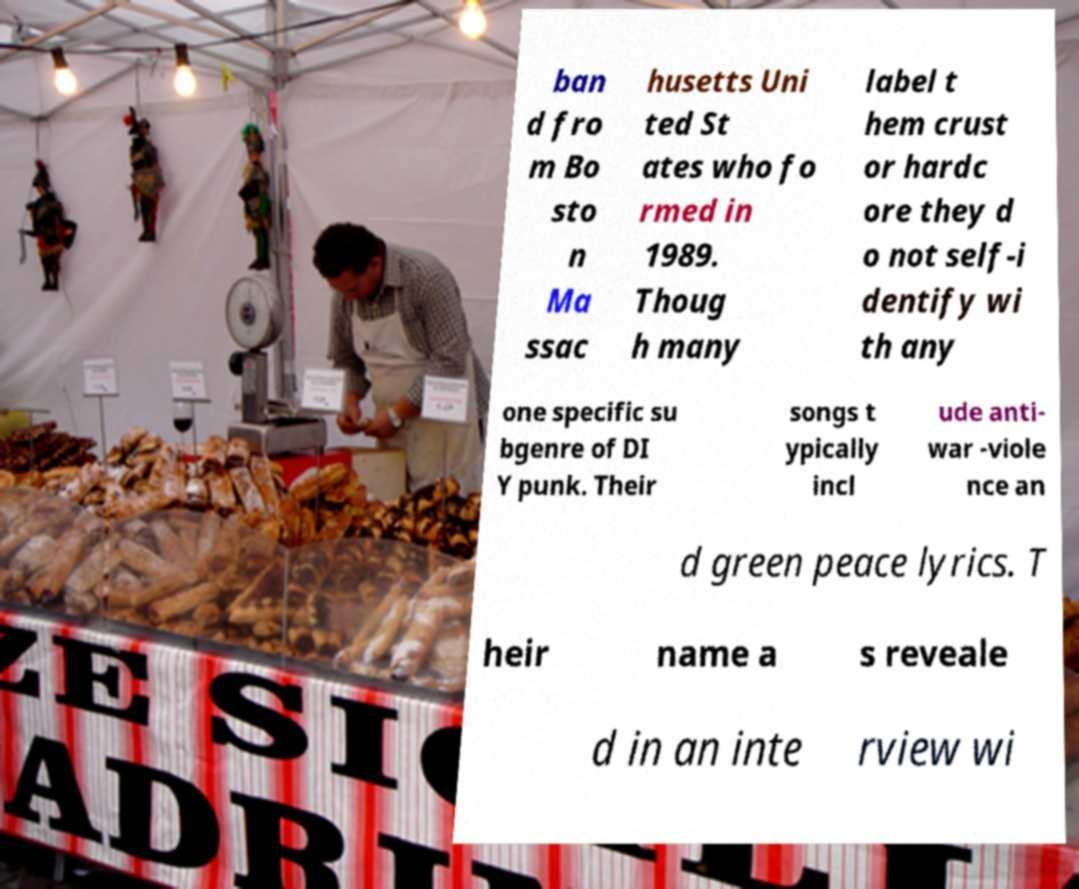Could you assist in decoding the text presented in this image and type it out clearly? ban d fro m Bo sto n Ma ssac husetts Uni ted St ates who fo rmed in 1989. Thoug h many label t hem crust or hardc ore they d o not self-i dentify wi th any one specific su bgenre of DI Y punk. Their songs t ypically incl ude anti- war -viole nce an d green peace lyrics. T heir name a s reveale d in an inte rview wi 